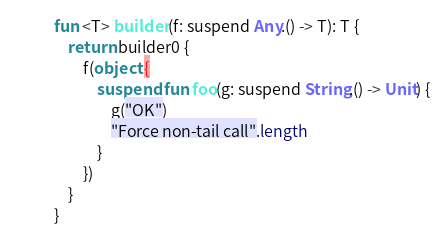<code> <loc_0><loc_0><loc_500><loc_500><_Kotlin_>fun <T> builder(f: suspend Any.() -> T): T {
    return builder0 {
        f(object {
            suspend fun foo(g: suspend String.() -> Unit) {
                g("OK")
                "Force non-tail call".length
            }
        })
    }
}
</code> 